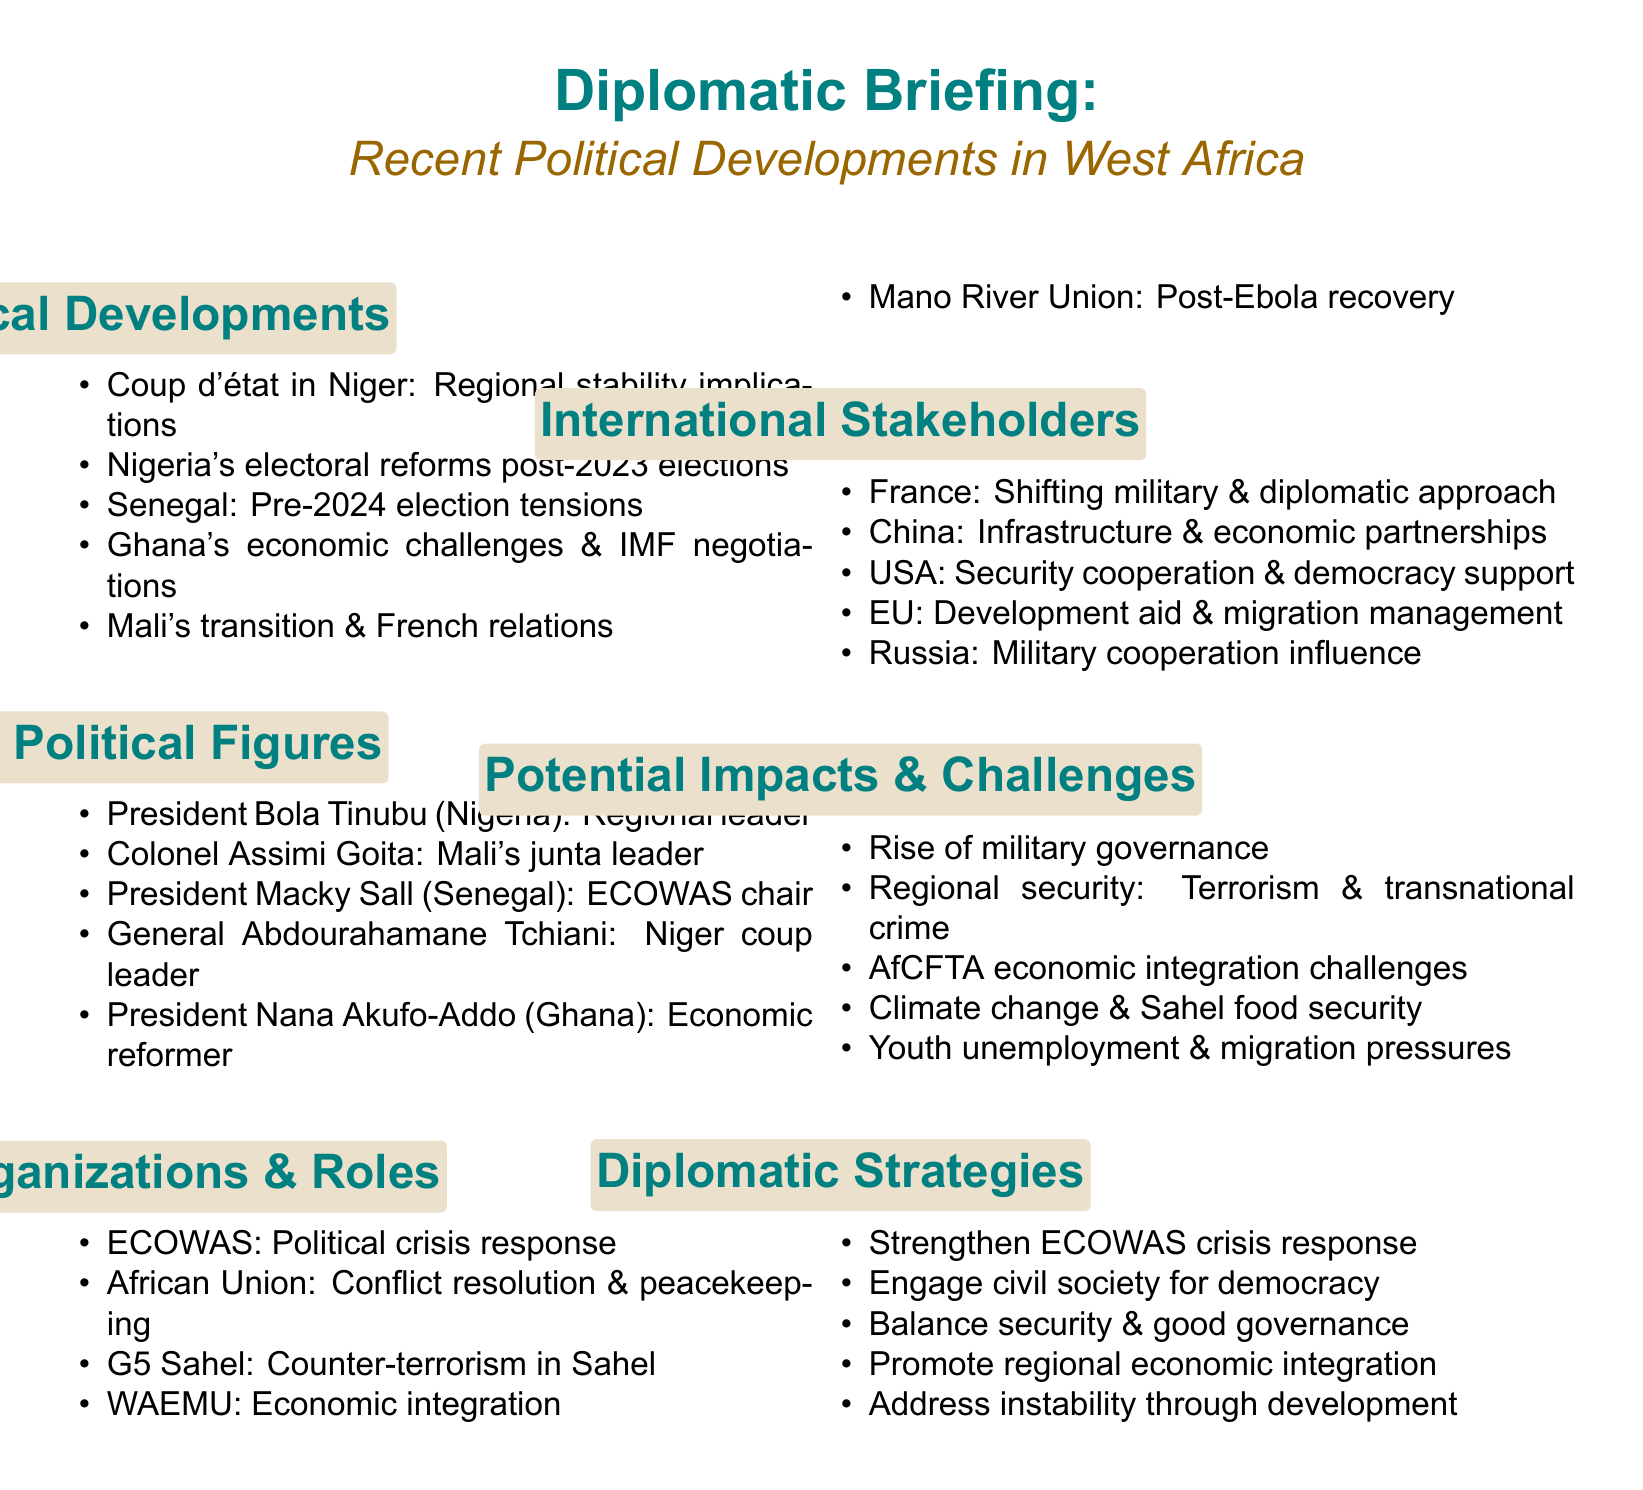What coup occurred recently in West Africa? The document mentions a coup d'état in Niger as a key political development.
Answer: Niger Who is the leader of Mali's military junta? The document identifies Colonel Assimi Goita as the leader of Mali's military junta under influential political figures.
Answer: Colonel Assimi Goita What organization is addressing the political crises and coup attempts in West Africa? The document highlights ECOWAS as a key regional organization responding to political crises and coup attempts.
Answer: ECOWAS Which international stakeholder is noted for shifting its military presence in the region? The document states that France is transitioning its military presence and diplomatic approach in West Africa.
Answer: France What economic challenge is Ghana facing according to the briefing? The document discusses Ghana's economic challenges and negotiations with the IMF as significant issues.
Answer: Economic challenges What is one of the potential impacts mentioned regarding governance in West Africa? The document describes the rise of military governance as a notable potential impact and challenge within the region.
Answer: Military governance What is suggested as a strategy to strengthen crisis response? The document recommends strengthening ECOWAS mechanisms for political crisis response as a diplomatic strategy.
Answer: Strengthening ECOWAS mechanisms Which influential political figure is the President of Nigeria? The document lists President Bola Tinubu of Nigeria as an influential political figure in the region.
Answer: President Bola Tinubu Which region is highlighted for counter-terrorism efforts? The document notes the G5 Sahel as an organization focused on counter-terrorism efforts in the Sahel region.
Answer: Sahel What is mentioned as a significant factor related to youth in West Africa? The document points out youth unemployment and migration pressures as major issues affecting the region.
Answer: Youth unemployment 